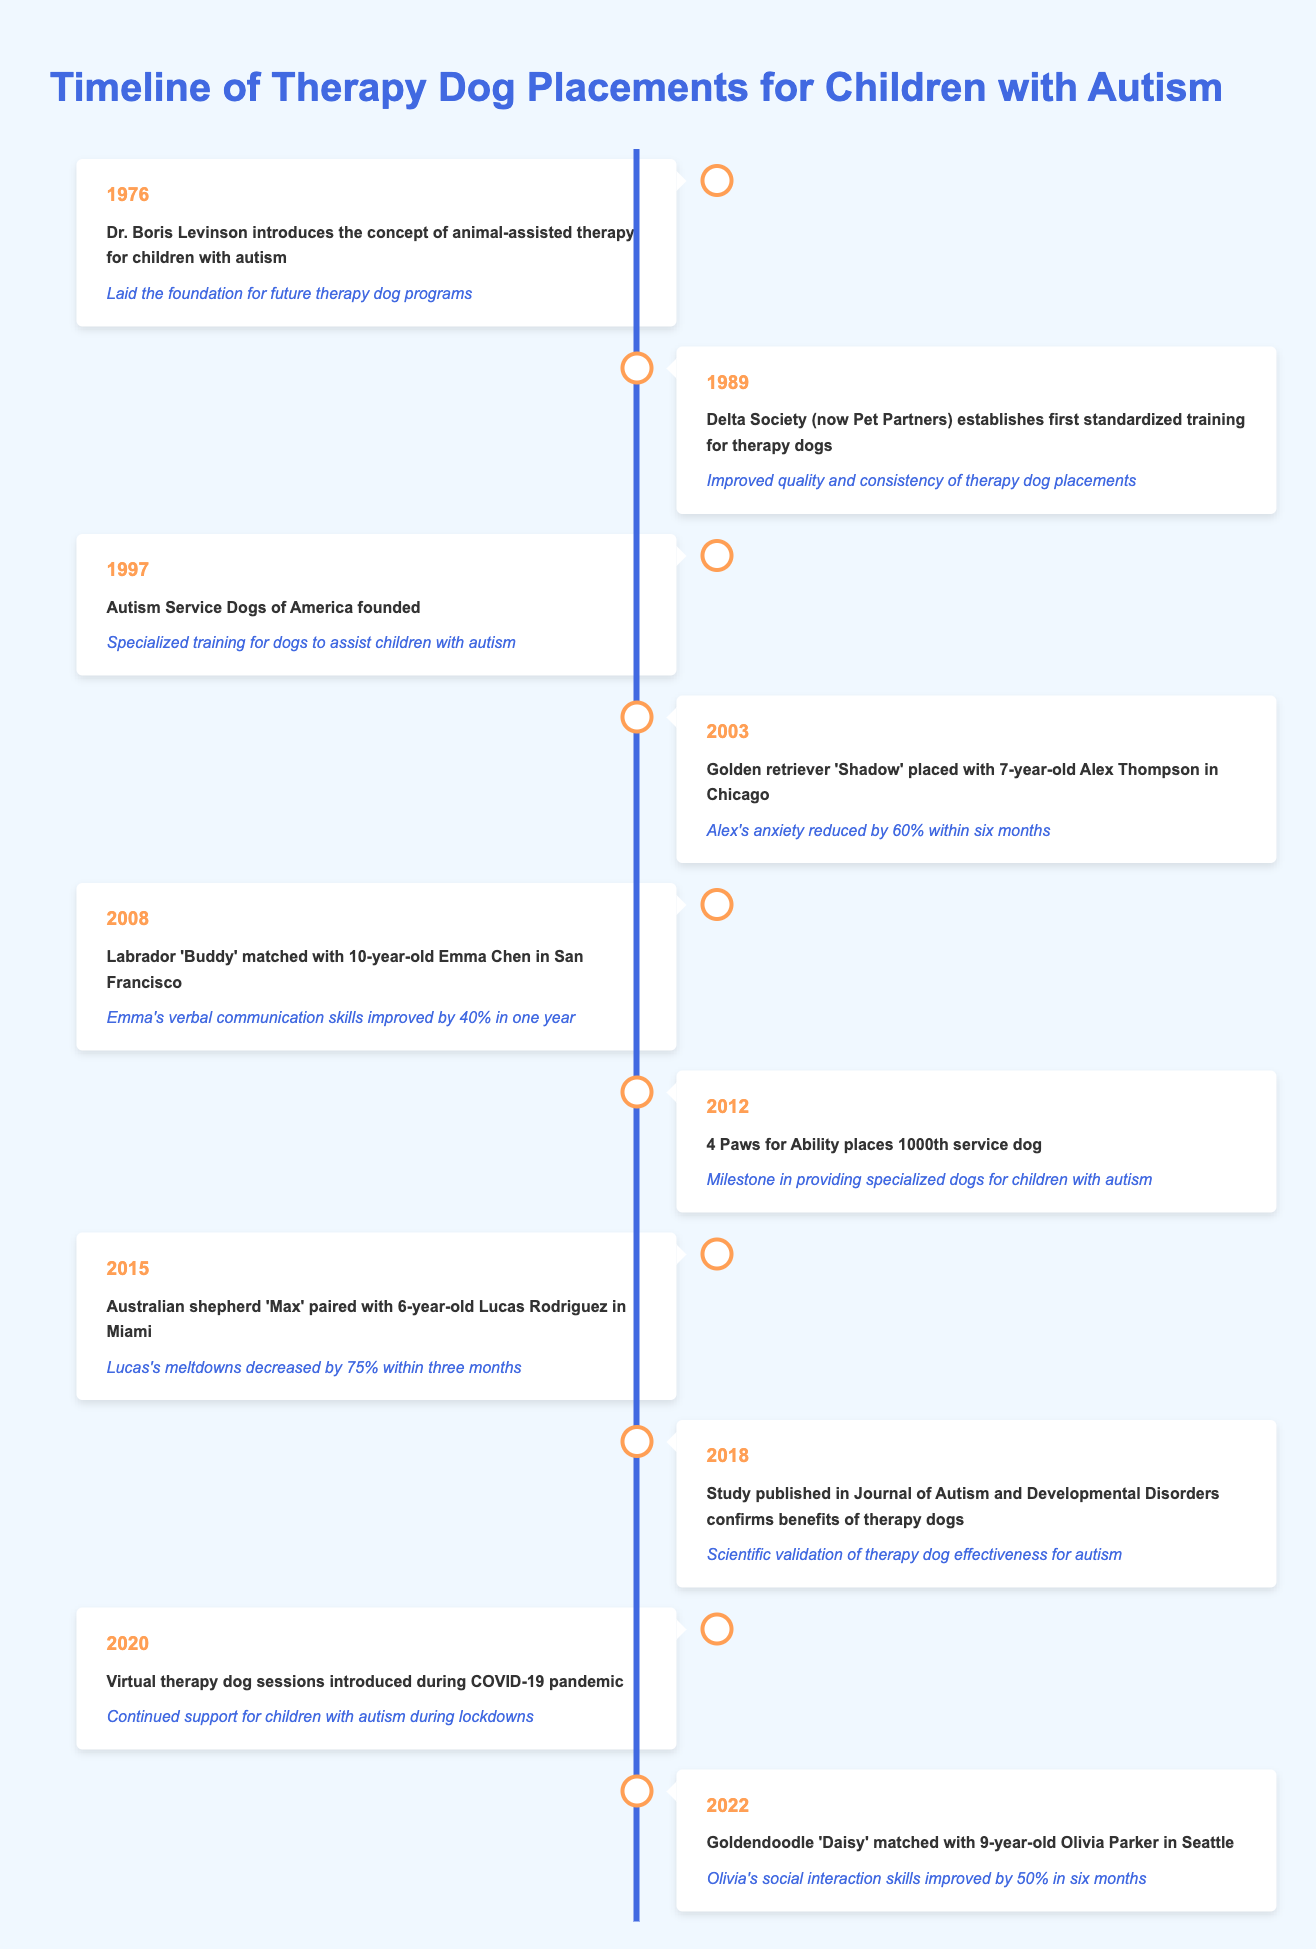What year did Dr. Boris Levinson introduce animal-assisted therapy for children with autism? The table indicates that Dr. Boris Levinson introduced this concept in 1976.
Answer: 1976 What impact did the placement of Golden retriever 'Shadow' have on Alex Thompson? The timeline specifies that Alex's anxiety was reduced by 60% within six months of being placed with 'Shadow'.
Answer: Alex's anxiety reduced by 60% Was the 1000th service dog placed by 4 Paws for Ability in 2012? According to the table, the placement of the 1000th service dog occurred in 2012, which supports the statement.
Answer: Yes How much did Emma Chen's verbal communication skills improve? The table states Emma's verbal communication skills improved by 40% in one year after being matched with 'Buddy'.
Answer: 40% What is the total amount of time it took for Lucas Rodriguez's meltdowns to decrease by 75% after being paired with 'Max'? 'Max' was paired with Lucas in 2015, and the reduction in meltdowns occurred within three months, which means it took a total of 3 months for this improvement to be noted.
Answer: 3 months What percentage improvement in social interaction skills did Olivia Parker experience? The impact mentioned for Olivia Parker indicates that her social interaction skills improved by 50% within six months of being matched with 'Daisy'.
Answer: 50% Did the study published in 2018 confirm benefits for therapy dogs for autism? The timeline confirms that a study published in 2018 indeed validated the benefits of therapy dogs for autism, making the statement true.
Answer: Yes Which therapy dog placement resulted in a child's anxiety being reduced the most, based on the timeline? Comparing the impacts listed, Lucas Rodriguez's meltdowns decreased by 75%, while others showed lesser reductions, making this the highest.
Answer: Max (Lucas Rodriguez) What is the average impact reduction in anxiety and meltdowns among the placements listed? To find the average, we take the reductions: 60%, 40%, 75% (from Alex, Emma, and Lucas), and calculate (60 + 40 + 75) / 3 = 58.33%. Therefore, the average impact reduction is approximately 58.33%.
Answer: 58.33% 